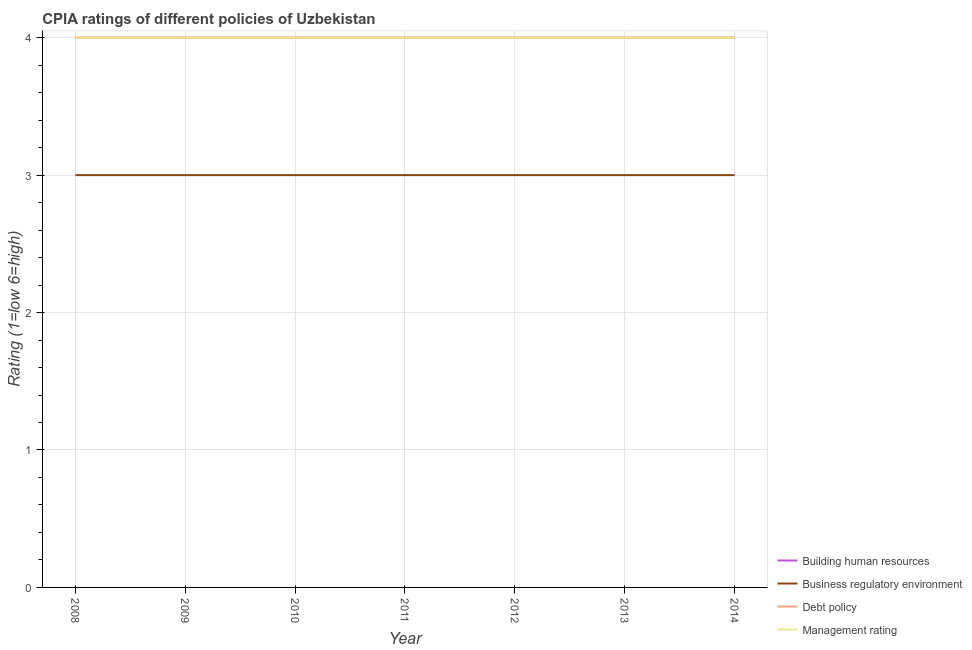Does the line corresponding to cpia rating of building human resources intersect with the line corresponding to cpia rating of debt policy?
Make the answer very short. Yes. Is the number of lines equal to the number of legend labels?
Ensure brevity in your answer.  Yes. What is the cpia rating of debt policy in 2008?
Ensure brevity in your answer.  4. Across all years, what is the maximum cpia rating of debt policy?
Your response must be concise. 4. Across all years, what is the minimum cpia rating of building human resources?
Provide a short and direct response. 4. What is the total cpia rating of building human resources in the graph?
Give a very brief answer. 28. What is the difference between the cpia rating of debt policy in 2009 and that in 2010?
Your answer should be compact. 0. What is the difference between the cpia rating of business regulatory environment in 2011 and the cpia rating of debt policy in 2008?
Offer a very short reply. -1. What is the average cpia rating of business regulatory environment per year?
Keep it short and to the point. 3. In the year 2011, what is the difference between the cpia rating of debt policy and cpia rating of business regulatory environment?
Make the answer very short. 1. In how many years, is the cpia rating of management greater than 1.8?
Keep it short and to the point. 7. What is the ratio of the cpia rating of debt policy in 2008 to that in 2013?
Offer a terse response. 1. What is the difference between the highest and the lowest cpia rating of debt policy?
Keep it short and to the point. 0. In how many years, is the cpia rating of debt policy greater than the average cpia rating of debt policy taken over all years?
Make the answer very short. 0. Is the sum of the cpia rating of building human resources in 2010 and 2011 greater than the maximum cpia rating of business regulatory environment across all years?
Give a very brief answer. Yes. Is it the case that in every year, the sum of the cpia rating of management and cpia rating of debt policy is greater than the sum of cpia rating of business regulatory environment and cpia rating of building human resources?
Your response must be concise. Yes. Does the cpia rating of building human resources monotonically increase over the years?
Your answer should be very brief. No. Is the cpia rating of building human resources strictly greater than the cpia rating of debt policy over the years?
Offer a very short reply. No. What is the difference between two consecutive major ticks on the Y-axis?
Offer a very short reply. 1. Does the graph contain any zero values?
Your answer should be compact. No. Does the graph contain grids?
Give a very brief answer. Yes. What is the title of the graph?
Keep it short and to the point. CPIA ratings of different policies of Uzbekistan. What is the label or title of the X-axis?
Provide a succinct answer. Year. What is the label or title of the Y-axis?
Your answer should be very brief. Rating (1=low 6=high). What is the Rating (1=low 6=high) in Business regulatory environment in 2008?
Your response must be concise. 3. What is the Rating (1=low 6=high) in Debt policy in 2008?
Offer a very short reply. 4. What is the Rating (1=low 6=high) in Management rating in 2008?
Offer a terse response. 4. What is the Rating (1=low 6=high) in Management rating in 2009?
Provide a succinct answer. 4. What is the Rating (1=low 6=high) of Debt policy in 2010?
Your answer should be compact. 4. What is the Rating (1=low 6=high) in Management rating in 2010?
Offer a very short reply. 4. What is the Rating (1=low 6=high) in Debt policy in 2011?
Your answer should be compact. 4. What is the Rating (1=low 6=high) in Building human resources in 2012?
Make the answer very short. 4. What is the Rating (1=low 6=high) of Management rating in 2012?
Give a very brief answer. 4. What is the Rating (1=low 6=high) in Business regulatory environment in 2013?
Your answer should be very brief. 3. What is the Rating (1=low 6=high) in Debt policy in 2013?
Offer a terse response. 4. What is the Rating (1=low 6=high) in Management rating in 2013?
Keep it short and to the point. 4. What is the Rating (1=low 6=high) of Business regulatory environment in 2014?
Offer a terse response. 3. What is the Rating (1=low 6=high) in Debt policy in 2014?
Ensure brevity in your answer.  4. Across all years, what is the maximum Rating (1=low 6=high) in Business regulatory environment?
Ensure brevity in your answer.  3. Across all years, what is the maximum Rating (1=low 6=high) of Management rating?
Give a very brief answer. 4. Across all years, what is the minimum Rating (1=low 6=high) in Business regulatory environment?
Make the answer very short. 3. What is the total Rating (1=low 6=high) of Business regulatory environment in the graph?
Give a very brief answer. 21. What is the total Rating (1=low 6=high) of Debt policy in the graph?
Provide a short and direct response. 28. What is the difference between the Rating (1=low 6=high) in Building human resources in 2008 and that in 2009?
Provide a short and direct response. 0. What is the difference between the Rating (1=low 6=high) of Management rating in 2008 and that in 2009?
Offer a very short reply. 0. What is the difference between the Rating (1=low 6=high) in Business regulatory environment in 2008 and that in 2010?
Your response must be concise. 0. What is the difference between the Rating (1=low 6=high) in Management rating in 2008 and that in 2010?
Offer a terse response. 0. What is the difference between the Rating (1=low 6=high) of Debt policy in 2008 and that in 2011?
Your answer should be very brief. 0. What is the difference between the Rating (1=low 6=high) in Building human resources in 2008 and that in 2012?
Provide a short and direct response. 0. What is the difference between the Rating (1=low 6=high) in Debt policy in 2008 and that in 2012?
Offer a very short reply. 0. What is the difference between the Rating (1=low 6=high) in Management rating in 2008 and that in 2012?
Offer a terse response. 0. What is the difference between the Rating (1=low 6=high) of Business regulatory environment in 2008 and that in 2013?
Keep it short and to the point. 0. What is the difference between the Rating (1=low 6=high) in Debt policy in 2008 and that in 2013?
Keep it short and to the point. 0. What is the difference between the Rating (1=low 6=high) in Building human resources in 2008 and that in 2014?
Provide a short and direct response. 0. What is the difference between the Rating (1=low 6=high) of Business regulatory environment in 2008 and that in 2014?
Keep it short and to the point. 0. What is the difference between the Rating (1=low 6=high) of Debt policy in 2008 and that in 2014?
Provide a succinct answer. 0. What is the difference between the Rating (1=low 6=high) in Management rating in 2008 and that in 2014?
Ensure brevity in your answer.  0. What is the difference between the Rating (1=low 6=high) in Business regulatory environment in 2009 and that in 2010?
Offer a very short reply. 0. What is the difference between the Rating (1=low 6=high) in Debt policy in 2009 and that in 2010?
Your answer should be very brief. 0. What is the difference between the Rating (1=low 6=high) of Management rating in 2009 and that in 2010?
Give a very brief answer. 0. What is the difference between the Rating (1=low 6=high) of Management rating in 2009 and that in 2011?
Ensure brevity in your answer.  0. What is the difference between the Rating (1=low 6=high) in Building human resources in 2009 and that in 2012?
Give a very brief answer. 0. What is the difference between the Rating (1=low 6=high) of Building human resources in 2009 and that in 2013?
Provide a succinct answer. 0. What is the difference between the Rating (1=low 6=high) of Management rating in 2009 and that in 2013?
Your answer should be compact. 0. What is the difference between the Rating (1=low 6=high) in Building human resources in 2009 and that in 2014?
Ensure brevity in your answer.  0. What is the difference between the Rating (1=low 6=high) in Management rating in 2009 and that in 2014?
Give a very brief answer. 0. What is the difference between the Rating (1=low 6=high) of Debt policy in 2010 and that in 2011?
Give a very brief answer. 0. What is the difference between the Rating (1=low 6=high) in Building human resources in 2010 and that in 2012?
Offer a terse response. 0. What is the difference between the Rating (1=low 6=high) in Management rating in 2010 and that in 2012?
Your answer should be very brief. 0. What is the difference between the Rating (1=low 6=high) of Building human resources in 2010 and that in 2013?
Your answer should be compact. 0. What is the difference between the Rating (1=low 6=high) in Business regulatory environment in 2010 and that in 2013?
Keep it short and to the point. 0. What is the difference between the Rating (1=low 6=high) of Building human resources in 2010 and that in 2014?
Provide a succinct answer. 0. What is the difference between the Rating (1=low 6=high) in Debt policy in 2010 and that in 2014?
Your answer should be compact. 0. What is the difference between the Rating (1=low 6=high) in Management rating in 2010 and that in 2014?
Offer a terse response. 0. What is the difference between the Rating (1=low 6=high) of Management rating in 2011 and that in 2012?
Provide a succinct answer. 0. What is the difference between the Rating (1=low 6=high) in Building human resources in 2011 and that in 2014?
Your answer should be very brief. 0. What is the difference between the Rating (1=low 6=high) in Business regulatory environment in 2012 and that in 2013?
Your response must be concise. 0. What is the difference between the Rating (1=low 6=high) of Debt policy in 2012 and that in 2013?
Keep it short and to the point. 0. What is the difference between the Rating (1=low 6=high) of Building human resources in 2012 and that in 2014?
Your answer should be compact. 0. What is the difference between the Rating (1=low 6=high) in Debt policy in 2012 and that in 2014?
Keep it short and to the point. 0. What is the difference between the Rating (1=low 6=high) in Management rating in 2012 and that in 2014?
Provide a short and direct response. 0. What is the difference between the Rating (1=low 6=high) of Building human resources in 2013 and that in 2014?
Make the answer very short. 0. What is the difference between the Rating (1=low 6=high) in Building human resources in 2008 and the Rating (1=low 6=high) in Debt policy in 2009?
Your answer should be very brief. 0. What is the difference between the Rating (1=low 6=high) in Building human resources in 2008 and the Rating (1=low 6=high) in Management rating in 2009?
Your answer should be compact. 0. What is the difference between the Rating (1=low 6=high) in Business regulatory environment in 2008 and the Rating (1=low 6=high) in Debt policy in 2009?
Provide a short and direct response. -1. What is the difference between the Rating (1=low 6=high) of Debt policy in 2008 and the Rating (1=low 6=high) of Management rating in 2009?
Keep it short and to the point. 0. What is the difference between the Rating (1=low 6=high) in Building human resources in 2008 and the Rating (1=low 6=high) in Business regulatory environment in 2010?
Your answer should be very brief. 1. What is the difference between the Rating (1=low 6=high) of Building human resources in 2008 and the Rating (1=low 6=high) of Debt policy in 2010?
Your answer should be compact. 0. What is the difference between the Rating (1=low 6=high) in Business regulatory environment in 2008 and the Rating (1=low 6=high) in Debt policy in 2010?
Offer a very short reply. -1. What is the difference between the Rating (1=low 6=high) of Business regulatory environment in 2008 and the Rating (1=low 6=high) of Management rating in 2010?
Your answer should be very brief. -1. What is the difference between the Rating (1=low 6=high) of Business regulatory environment in 2008 and the Rating (1=low 6=high) of Management rating in 2011?
Make the answer very short. -1. What is the difference between the Rating (1=low 6=high) of Debt policy in 2008 and the Rating (1=low 6=high) of Management rating in 2011?
Offer a very short reply. 0. What is the difference between the Rating (1=low 6=high) of Building human resources in 2008 and the Rating (1=low 6=high) of Debt policy in 2012?
Your answer should be very brief. 0. What is the difference between the Rating (1=low 6=high) of Business regulatory environment in 2008 and the Rating (1=low 6=high) of Debt policy in 2012?
Ensure brevity in your answer.  -1. What is the difference between the Rating (1=low 6=high) in Building human resources in 2008 and the Rating (1=low 6=high) in Business regulatory environment in 2013?
Keep it short and to the point. 1. What is the difference between the Rating (1=low 6=high) of Business regulatory environment in 2008 and the Rating (1=low 6=high) of Debt policy in 2013?
Ensure brevity in your answer.  -1. What is the difference between the Rating (1=low 6=high) in Business regulatory environment in 2008 and the Rating (1=low 6=high) in Management rating in 2013?
Offer a very short reply. -1. What is the difference between the Rating (1=low 6=high) of Debt policy in 2008 and the Rating (1=low 6=high) of Management rating in 2013?
Provide a succinct answer. 0. What is the difference between the Rating (1=low 6=high) of Building human resources in 2008 and the Rating (1=low 6=high) of Business regulatory environment in 2014?
Offer a terse response. 1. What is the difference between the Rating (1=low 6=high) of Building human resources in 2009 and the Rating (1=low 6=high) of Debt policy in 2010?
Offer a terse response. 0. What is the difference between the Rating (1=low 6=high) in Building human resources in 2009 and the Rating (1=low 6=high) in Management rating in 2010?
Provide a short and direct response. 0. What is the difference between the Rating (1=low 6=high) of Debt policy in 2009 and the Rating (1=low 6=high) of Management rating in 2010?
Keep it short and to the point. 0. What is the difference between the Rating (1=low 6=high) of Building human resources in 2009 and the Rating (1=low 6=high) of Management rating in 2011?
Offer a very short reply. 0. What is the difference between the Rating (1=low 6=high) in Business regulatory environment in 2009 and the Rating (1=low 6=high) in Debt policy in 2011?
Make the answer very short. -1. What is the difference between the Rating (1=low 6=high) of Business regulatory environment in 2009 and the Rating (1=low 6=high) of Management rating in 2011?
Your response must be concise. -1. What is the difference between the Rating (1=low 6=high) of Building human resources in 2009 and the Rating (1=low 6=high) of Debt policy in 2012?
Ensure brevity in your answer.  0. What is the difference between the Rating (1=low 6=high) of Building human resources in 2009 and the Rating (1=low 6=high) of Management rating in 2012?
Make the answer very short. 0. What is the difference between the Rating (1=low 6=high) in Debt policy in 2009 and the Rating (1=low 6=high) in Management rating in 2012?
Your answer should be compact. 0. What is the difference between the Rating (1=low 6=high) in Building human resources in 2009 and the Rating (1=low 6=high) in Debt policy in 2013?
Make the answer very short. 0. What is the difference between the Rating (1=low 6=high) in Business regulatory environment in 2009 and the Rating (1=low 6=high) in Management rating in 2013?
Your answer should be very brief. -1. What is the difference between the Rating (1=low 6=high) of Building human resources in 2009 and the Rating (1=low 6=high) of Debt policy in 2014?
Keep it short and to the point. 0. What is the difference between the Rating (1=low 6=high) of Building human resources in 2009 and the Rating (1=low 6=high) of Management rating in 2014?
Offer a terse response. 0. What is the difference between the Rating (1=low 6=high) in Business regulatory environment in 2009 and the Rating (1=low 6=high) in Debt policy in 2014?
Keep it short and to the point. -1. What is the difference between the Rating (1=low 6=high) of Business regulatory environment in 2009 and the Rating (1=low 6=high) of Management rating in 2014?
Provide a succinct answer. -1. What is the difference between the Rating (1=low 6=high) in Debt policy in 2009 and the Rating (1=low 6=high) in Management rating in 2014?
Give a very brief answer. 0. What is the difference between the Rating (1=low 6=high) in Building human resources in 2010 and the Rating (1=low 6=high) in Business regulatory environment in 2011?
Your response must be concise. 1. What is the difference between the Rating (1=low 6=high) of Building human resources in 2010 and the Rating (1=low 6=high) of Debt policy in 2011?
Make the answer very short. 0. What is the difference between the Rating (1=low 6=high) in Debt policy in 2010 and the Rating (1=low 6=high) in Management rating in 2011?
Your response must be concise. 0. What is the difference between the Rating (1=low 6=high) of Business regulatory environment in 2010 and the Rating (1=low 6=high) of Debt policy in 2012?
Offer a very short reply. -1. What is the difference between the Rating (1=low 6=high) of Building human resources in 2010 and the Rating (1=low 6=high) of Business regulatory environment in 2014?
Give a very brief answer. 1. What is the difference between the Rating (1=low 6=high) of Building human resources in 2010 and the Rating (1=low 6=high) of Management rating in 2014?
Provide a short and direct response. 0. What is the difference between the Rating (1=low 6=high) of Business regulatory environment in 2010 and the Rating (1=low 6=high) of Debt policy in 2014?
Your response must be concise. -1. What is the difference between the Rating (1=low 6=high) in Business regulatory environment in 2010 and the Rating (1=low 6=high) in Management rating in 2014?
Ensure brevity in your answer.  -1. What is the difference between the Rating (1=low 6=high) of Debt policy in 2010 and the Rating (1=low 6=high) of Management rating in 2014?
Your response must be concise. 0. What is the difference between the Rating (1=low 6=high) in Building human resources in 2011 and the Rating (1=low 6=high) in Business regulatory environment in 2012?
Offer a terse response. 1. What is the difference between the Rating (1=low 6=high) of Building human resources in 2011 and the Rating (1=low 6=high) of Debt policy in 2012?
Make the answer very short. 0. What is the difference between the Rating (1=low 6=high) in Business regulatory environment in 2011 and the Rating (1=low 6=high) in Debt policy in 2012?
Keep it short and to the point. -1. What is the difference between the Rating (1=low 6=high) in Building human resources in 2011 and the Rating (1=low 6=high) in Business regulatory environment in 2013?
Ensure brevity in your answer.  1. What is the difference between the Rating (1=low 6=high) in Business regulatory environment in 2011 and the Rating (1=low 6=high) in Management rating in 2013?
Ensure brevity in your answer.  -1. What is the difference between the Rating (1=low 6=high) of Debt policy in 2011 and the Rating (1=low 6=high) of Management rating in 2013?
Offer a very short reply. 0. What is the difference between the Rating (1=low 6=high) in Building human resources in 2011 and the Rating (1=low 6=high) in Business regulatory environment in 2014?
Give a very brief answer. 1. What is the difference between the Rating (1=low 6=high) in Building human resources in 2011 and the Rating (1=low 6=high) in Debt policy in 2014?
Your response must be concise. 0. What is the difference between the Rating (1=low 6=high) in Building human resources in 2011 and the Rating (1=low 6=high) in Management rating in 2014?
Keep it short and to the point. 0. What is the difference between the Rating (1=low 6=high) in Business regulatory environment in 2011 and the Rating (1=low 6=high) in Debt policy in 2014?
Ensure brevity in your answer.  -1. What is the difference between the Rating (1=low 6=high) in Business regulatory environment in 2011 and the Rating (1=low 6=high) in Management rating in 2014?
Offer a terse response. -1. What is the difference between the Rating (1=low 6=high) in Building human resources in 2012 and the Rating (1=low 6=high) in Debt policy in 2013?
Offer a terse response. 0. What is the difference between the Rating (1=low 6=high) of Building human resources in 2012 and the Rating (1=low 6=high) of Management rating in 2013?
Your answer should be compact. 0. What is the difference between the Rating (1=low 6=high) of Business regulatory environment in 2012 and the Rating (1=low 6=high) of Management rating in 2013?
Your answer should be very brief. -1. What is the difference between the Rating (1=low 6=high) in Building human resources in 2012 and the Rating (1=low 6=high) in Business regulatory environment in 2014?
Ensure brevity in your answer.  1. What is the difference between the Rating (1=low 6=high) in Building human resources in 2012 and the Rating (1=low 6=high) in Management rating in 2014?
Offer a very short reply. 0. What is the difference between the Rating (1=low 6=high) of Business regulatory environment in 2012 and the Rating (1=low 6=high) of Management rating in 2014?
Offer a terse response. -1. What is the difference between the Rating (1=low 6=high) of Debt policy in 2012 and the Rating (1=low 6=high) of Management rating in 2014?
Provide a short and direct response. 0. What is the difference between the Rating (1=low 6=high) in Building human resources in 2013 and the Rating (1=low 6=high) in Business regulatory environment in 2014?
Ensure brevity in your answer.  1. What is the difference between the Rating (1=low 6=high) of Business regulatory environment in 2013 and the Rating (1=low 6=high) of Debt policy in 2014?
Give a very brief answer. -1. What is the difference between the Rating (1=low 6=high) in Business regulatory environment in 2013 and the Rating (1=low 6=high) in Management rating in 2014?
Ensure brevity in your answer.  -1. What is the average Rating (1=low 6=high) in Building human resources per year?
Keep it short and to the point. 4. What is the average Rating (1=low 6=high) of Business regulatory environment per year?
Provide a short and direct response. 3. In the year 2008, what is the difference between the Rating (1=low 6=high) in Building human resources and Rating (1=low 6=high) in Business regulatory environment?
Offer a very short reply. 1. In the year 2008, what is the difference between the Rating (1=low 6=high) of Building human resources and Rating (1=low 6=high) of Debt policy?
Provide a short and direct response. 0. In the year 2008, what is the difference between the Rating (1=low 6=high) in Debt policy and Rating (1=low 6=high) in Management rating?
Your answer should be compact. 0. In the year 2009, what is the difference between the Rating (1=low 6=high) in Building human resources and Rating (1=low 6=high) in Business regulatory environment?
Keep it short and to the point. 1. In the year 2009, what is the difference between the Rating (1=low 6=high) in Building human resources and Rating (1=low 6=high) in Debt policy?
Your response must be concise. 0. In the year 2009, what is the difference between the Rating (1=low 6=high) of Building human resources and Rating (1=low 6=high) of Management rating?
Your answer should be very brief. 0. In the year 2009, what is the difference between the Rating (1=low 6=high) of Business regulatory environment and Rating (1=low 6=high) of Debt policy?
Keep it short and to the point. -1. In the year 2009, what is the difference between the Rating (1=low 6=high) in Debt policy and Rating (1=low 6=high) in Management rating?
Provide a succinct answer. 0. In the year 2010, what is the difference between the Rating (1=low 6=high) of Building human resources and Rating (1=low 6=high) of Management rating?
Give a very brief answer. 0. In the year 2010, what is the difference between the Rating (1=low 6=high) of Business regulatory environment and Rating (1=low 6=high) of Debt policy?
Give a very brief answer. -1. In the year 2011, what is the difference between the Rating (1=low 6=high) in Building human resources and Rating (1=low 6=high) in Debt policy?
Ensure brevity in your answer.  0. In the year 2011, what is the difference between the Rating (1=low 6=high) in Business regulatory environment and Rating (1=low 6=high) in Debt policy?
Your answer should be compact. -1. In the year 2012, what is the difference between the Rating (1=low 6=high) of Business regulatory environment and Rating (1=low 6=high) of Debt policy?
Provide a short and direct response. -1. In the year 2013, what is the difference between the Rating (1=low 6=high) of Building human resources and Rating (1=low 6=high) of Debt policy?
Offer a very short reply. 0. In the year 2013, what is the difference between the Rating (1=low 6=high) of Building human resources and Rating (1=low 6=high) of Management rating?
Offer a very short reply. 0. In the year 2013, what is the difference between the Rating (1=low 6=high) of Business regulatory environment and Rating (1=low 6=high) of Debt policy?
Ensure brevity in your answer.  -1. In the year 2013, what is the difference between the Rating (1=low 6=high) of Debt policy and Rating (1=low 6=high) of Management rating?
Make the answer very short. 0. In the year 2014, what is the difference between the Rating (1=low 6=high) of Building human resources and Rating (1=low 6=high) of Business regulatory environment?
Offer a very short reply. 1. In the year 2014, what is the difference between the Rating (1=low 6=high) in Building human resources and Rating (1=low 6=high) in Debt policy?
Your answer should be compact. 0. In the year 2014, what is the difference between the Rating (1=low 6=high) in Building human resources and Rating (1=low 6=high) in Management rating?
Your answer should be compact. 0. In the year 2014, what is the difference between the Rating (1=low 6=high) of Business regulatory environment and Rating (1=low 6=high) of Debt policy?
Your answer should be very brief. -1. In the year 2014, what is the difference between the Rating (1=low 6=high) in Business regulatory environment and Rating (1=low 6=high) in Management rating?
Your answer should be very brief. -1. What is the ratio of the Rating (1=low 6=high) of Business regulatory environment in 2008 to that in 2009?
Ensure brevity in your answer.  1. What is the ratio of the Rating (1=low 6=high) in Debt policy in 2008 to that in 2009?
Your answer should be very brief. 1. What is the ratio of the Rating (1=low 6=high) of Business regulatory environment in 2008 to that in 2011?
Offer a very short reply. 1. What is the ratio of the Rating (1=low 6=high) of Management rating in 2008 to that in 2011?
Your response must be concise. 1. What is the ratio of the Rating (1=low 6=high) of Business regulatory environment in 2008 to that in 2012?
Your answer should be compact. 1. What is the ratio of the Rating (1=low 6=high) in Debt policy in 2008 to that in 2012?
Offer a very short reply. 1. What is the ratio of the Rating (1=low 6=high) of Management rating in 2008 to that in 2012?
Your answer should be very brief. 1. What is the ratio of the Rating (1=low 6=high) of Building human resources in 2008 to that in 2013?
Ensure brevity in your answer.  1. What is the ratio of the Rating (1=low 6=high) in Debt policy in 2008 to that in 2013?
Your response must be concise. 1. What is the ratio of the Rating (1=low 6=high) in Business regulatory environment in 2008 to that in 2014?
Your response must be concise. 1. What is the ratio of the Rating (1=low 6=high) of Debt policy in 2009 to that in 2011?
Provide a short and direct response. 1. What is the ratio of the Rating (1=low 6=high) of Building human resources in 2009 to that in 2012?
Your response must be concise. 1. What is the ratio of the Rating (1=low 6=high) in Debt policy in 2009 to that in 2012?
Your answer should be compact. 1. What is the ratio of the Rating (1=low 6=high) of Management rating in 2009 to that in 2012?
Provide a short and direct response. 1. What is the ratio of the Rating (1=low 6=high) of Building human resources in 2009 to that in 2013?
Offer a very short reply. 1. What is the ratio of the Rating (1=low 6=high) in Business regulatory environment in 2009 to that in 2013?
Your answer should be compact. 1. What is the ratio of the Rating (1=low 6=high) in Management rating in 2009 to that in 2013?
Your answer should be very brief. 1. What is the ratio of the Rating (1=low 6=high) of Building human resources in 2009 to that in 2014?
Offer a very short reply. 1. What is the ratio of the Rating (1=low 6=high) in Business regulatory environment in 2009 to that in 2014?
Provide a succinct answer. 1. What is the ratio of the Rating (1=low 6=high) in Business regulatory environment in 2010 to that in 2011?
Offer a terse response. 1. What is the ratio of the Rating (1=low 6=high) in Management rating in 2010 to that in 2011?
Ensure brevity in your answer.  1. What is the ratio of the Rating (1=low 6=high) in Building human resources in 2010 to that in 2012?
Keep it short and to the point. 1. What is the ratio of the Rating (1=low 6=high) of Business regulatory environment in 2010 to that in 2012?
Your response must be concise. 1. What is the ratio of the Rating (1=low 6=high) of Business regulatory environment in 2010 to that in 2013?
Offer a terse response. 1. What is the ratio of the Rating (1=low 6=high) of Debt policy in 2010 to that in 2013?
Your answer should be compact. 1. What is the ratio of the Rating (1=low 6=high) in Business regulatory environment in 2010 to that in 2014?
Offer a terse response. 1. What is the ratio of the Rating (1=low 6=high) in Debt policy in 2010 to that in 2014?
Ensure brevity in your answer.  1. What is the ratio of the Rating (1=low 6=high) of Building human resources in 2011 to that in 2012?
Ensure brevity in your answer.  1. What is the ratio of the Rating (1=low 6=high) of Debt policy in 2011 to that in 2013?
Keep it short and to the point. 1. What is the ratio of the Rating (1=low 6=high) of Management rating in 2011 to that in 2014?
Make the answer very short. 1. What is the ratio of the Rating (1=low 6=high) in Building human resources in 2012 to that in 2013?
Your response must be concise. 1. What is the ratio of the Rating (1=low 6=high) of Business regulatory environment in 2012 to that in 2013?
Ensure brevity in your answer.  1. What is the ratio of the Rating (1=low 6=high) of Management rating in 2012 to that in 2013?
Your answer should be very brief. 1. What is the ratio of the Rating (1=low 6=high) in Debt policy in 2012 to that in 2014?
Offer a terse response. 1. What is the difference between the highest and the second highest Rating (1=low 6=high) of Building human resources?
Ensure brevity in your answer.  0. What is the difference between the highest and the lowest Rating (1=low 6=high) in Debt policy?
Give a very brief answer. 0. What is the difference between the highest and the lowest Rating (1=low 6=high) in Management rating?
Make the answer very short. 0. 